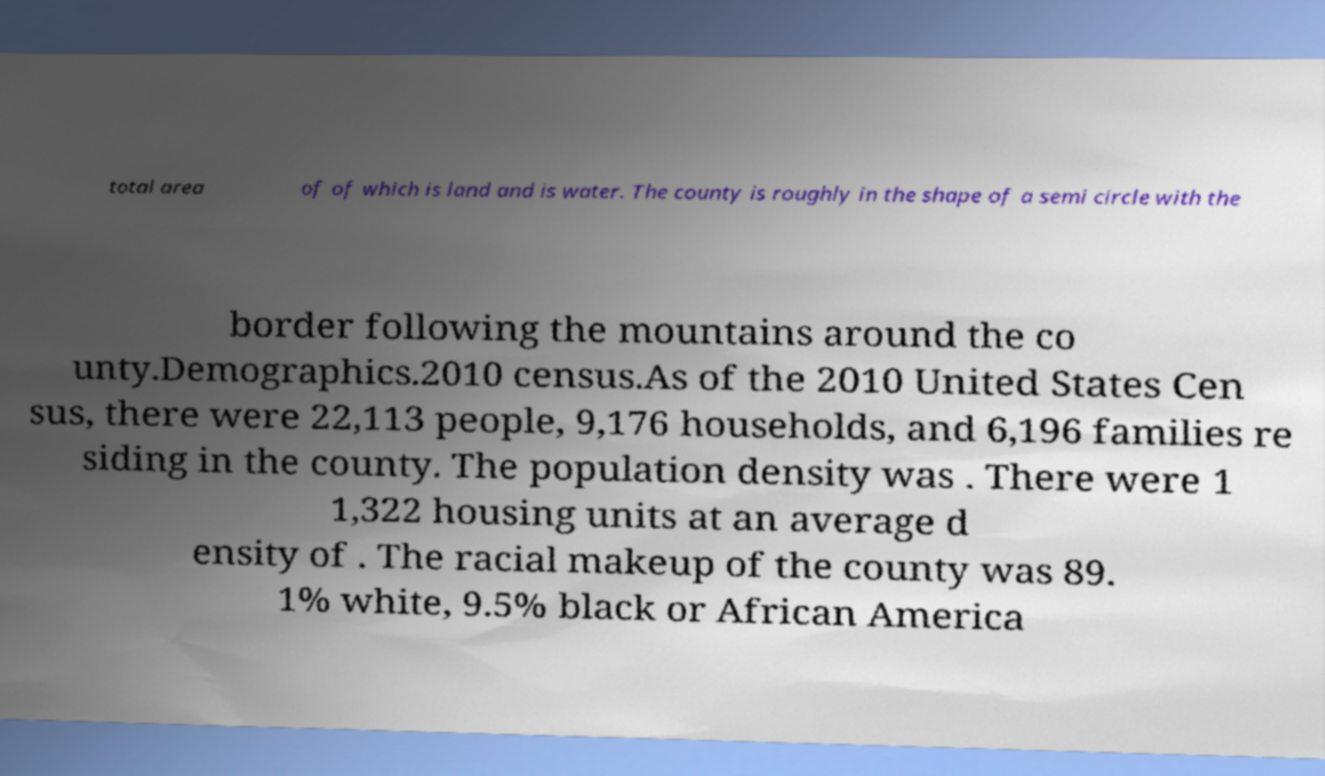Please read and relay the text visible in this image. What does it say? total area of of which is land and is water. The county is roughly in the shape of a semi circle with the border following the mountains around the co unty.Demographics.2010 census.As of the 2010 United States Cen sus, there were 22,113 people, 9,176 households, and 6,196 families re siding in the county. The population density was . There were 1 1,322 housing units at an average d ensity of . The racial makeup of the county was 89. 1% white, 9.5% black or African America 